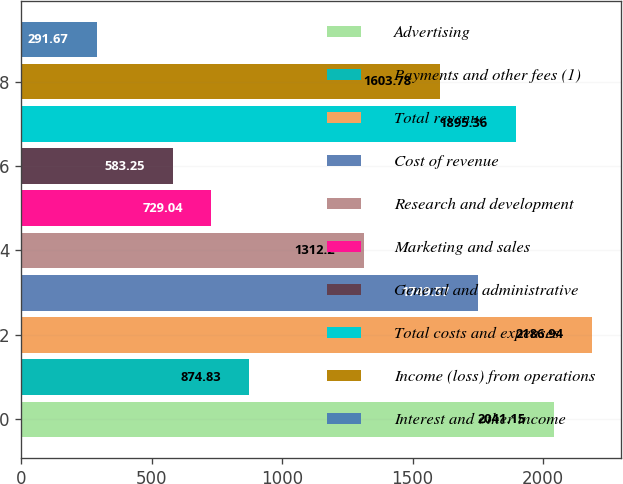Convert chart. <chart><loc_0><loc_0><loc_500><loc_500><bar_chart><fcel>Advertising<fcel>Payments and other fees (1)<fcel>Total revenue<fcel>Cost of revenue<fcel>Research and development<fcel>Marketing and sales<fcel>General and administrative<fcel>Total costs and expenses<fcel>Income (loss) from operations<fcel>Interest and other income<nl><fcel>2041.15<fcel>874.83<fcel>2186.94<fcel>1749.57<fcel>1312.2<fcel>729.04<fcel>583.25<fcel>1895.36<fcel>1603.78<fcel>291.67<nl></chart> 